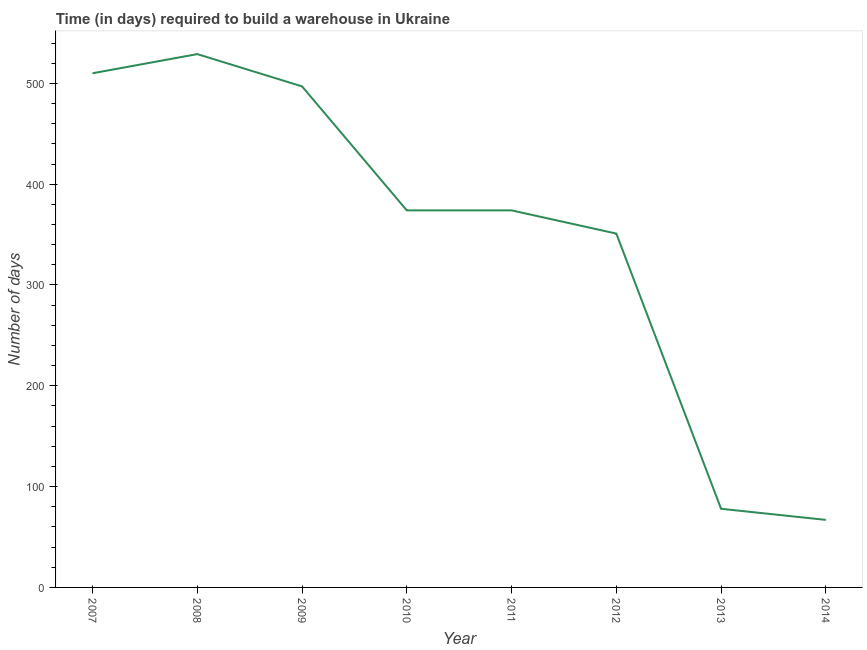What is the time required to build a warehouse in 2010?
Keep it short and to the point. 374. Across all years, what is the maximum time required to build a warehouse?
Offer a terse response. 529. Across all years, what is the minimum time required to build a warehouse?
Provide a succinct answer. 67. In which year was the time required to build a warehouse maximum?
Provide a short and direct response. 2008. What is the sum of the time required to build a warehouse?
Provide a short and direct response. 2780. What is the average time required to build a warehouse per year?
Give a very brief answer. 347.5. What is the median time required to build a warehouse?
Make the answer very short. 374. In how many years, is the time required to build a warehouse greater than 40 days?
Make the answer very short. 8. Do a majority of the years between 2013 and 2009 (inclusive) have time required to build a warehouse greater than 320 days?
Provide a succinct answer. Yes. What is the ratio of the time required to build a warehouse in 2009 to that in 2011?
Your answer should be compact. 1.33. Is the time required to build a warehouse in 2012 less than that in 2014?
Your answer should be very brief. No. Is the difference between the time required to build a warehouse in 2011 and 2013 greater than the difference between any two years?
Make the answer very short. No. What is the difference between the highest and the lowest time required to build a warehouse?
Provide a succinct answer. 462. In how many years, is the time required to build a warehouse greater than the average time required to build a warehouse taken over all years?
Your answer should be very brief. 6. Does the time required to build a warehouse monotonically increase over the years?
Keep it short and to the point. No. How many lines are there?
Provide a short and direct response. 1. Are the values on the major ticks of Y-axis written in scientific E-notation?
Make the answer very short. No. Does the graph contain any zero values?
Provide a succinct answer. No. Does the graph contain grids?
Your answer should be compact. No. What is the title of the graph?
Offer a terse response. Time (in days) required to build a warehouse in Ukraine. What is the label or title of the Y-axis?
Provide a short and direct response. Number of days. What is the Number of days in 2007?
Offer a very short reply. 510. What is the Number of days in 2008?
Make the answer very short. 529. What is the Number of days of 2009?
Ensure brevity in your answer.  497. What is the Number of days of 2010?
Your answer should be compact. 374. What is the Number of days in 2011?
Your answer should be very brief. 374. What is the Number of days of 2012?
Keep it short and to the point. 351. What is the difference between the Number of days in 2007 and 2009?
Keep it short and to the point. 13. What is the difference between the Number of days in 2007 and 2010?
Ensure brevity in your answer.  136. What is the difference between the Number of days in 2007 and 2011?
Your response must be concise. 136. What is the difference between the Number of days in 2007 and 2012?
Offer a very short reply. 159. What is the difference between the Number of days in 2007 and 2013?
Ensure brevity in your answer.  432. What is the difference between the Number of days in 2007 and 2014?
Give a very brief answer. 443. What is the difference between the Number of days in 2008 and 2009?
Keep it short and to the point. 32. What is the difference between the Number of days in 2008 and 2010?
Make the answer very short. 155. What is the difference between the Number of days in 2008 and 2011?
Ensure brevity in your answer.  155. What is the difference between the Number of days in 2008 and 2012?
Provide a short and direct response. 178. What is the difference between the Number of days in 2008 and 2013?
Offer a terse response. 451. What is the difference between the Number of days in 2008 and 2014?
Offer a terse response. 462. What is the difference between the Number of days in 2009 and 2010?
Make the answer very short. 123. What is the difference between the Number of days in 2009 and 2011?
Give a very brief answer. 123. What is the difference between the Number of days in 2009 and 2012?
Offer a very short reply. 146. What is the difference between the Number of days in 2009 and 2013?
Offer a very short reply. 419. What is the difference between the Number of days in 2009 and 2014?
Your answer should be very brief. 430. What is the difference between the Number of days in 2010 and 2013?
Provide a succinct answer. 296. What is the difference between the Number of days in 2010 and 2014?
Give a very brief answer. 307. What is the difference between the Number of days in 2011 and 2013?
Keep it short and to the point. 296. What is the difference between the Number of days in 2011 and 2014?
Provide a succinct answer. 307. What is the difference between the Number of days in 2012 and 2013?
Ensure brevity in your answer.  273. What is the difference between the Number of days in 2012 and 2014?
Your answer should be very brief. 284. What is the ratio of the Number of days in 2007 to that in 2010?
Give a very brief answer. 1.36. What is the ratio of the Number of days in 2007 to that in 2011?
Your response must be concise. 1.36. What is the ratio of the Number of days in 2007 to that in 2012?
Your answer should be compact. 1.45. What is the ratio of the Number of days in 2007 to that in 2013?
Ensure brevity in your answer.  6.54. What is the ratio of the Number of days in 2007 to that in 2014?
Offer a terse response. 7.61. What is the ratio of the Number of days in 2008 to that in 2009?
Make the answer very short. 1.06. What is the ratio of the Number of days in 2008 to that in 2010?
Provide a short and direct response. 1.41. What is the ratio of the Number of days in 2008 to that in 2011?
Your answer should be compact. 1.41. What is the ratio of the Number of days in 2008 to that in 2012?
Your response must be concise. 1.51. What is the ratio of the Number of days in 2008 to that in 2013?
Ensure brevity in your answer.  6.78. What is the ratio of the Number of days in 2008 to that in 2014?
Offer a terse response. 7.9. What is the ratio of the Number of days in 2009 to that in 2010?
Your response must be concise. 1.33. What is the ratio of the Number of days in 2009 to that in 2011?
Give a very brief answer. 1.33. What is the ratio of the Number of days in 2009 to that in 2012?
Give a very brief answer. 1.42. What is the ratio of the Number of days in 2009 to that in 2013?
Make the answer very short. 6.37. What is the ratio of the Number of days in 2009 to that in 2014?
Make the answer very short. 7.42. What is the ratio of the Number of days in 2010 to that in 2011?
Your answer should be compact. 1. What is the ratio of the Number of days in 2010 to that in 2012?
Your response must be concise. 1.07. What is the ratio of the Number of days in 2010 to that in 2013?
Offer a very short reply. 4.79. What is the ratio of the Number of days in 2010 to that in 2014?
Make the answer very short. 5.58. What is the ratio of the Number of days in 2011 to that in 2012?
Provide a succinct answer. 1.07. What is the ratio of the Number of days in 2011 to that in 2013?
Offer a terse response. 4.79. What is the ratio of the Number of days in 2011 to that in 2014?
Provide a succinct answer. 5.58. What is the ratio of the Number of days in 2012 to that in 2013?
Your response must be concise. 4.5. What is the ratio of the Number of days in 2012 to that in 2014?
Provide a succinct answer. 5.24. What is the ratio of the Number of days in 2013 to that in 2014?
Keep it short and to the point. 1.16. 